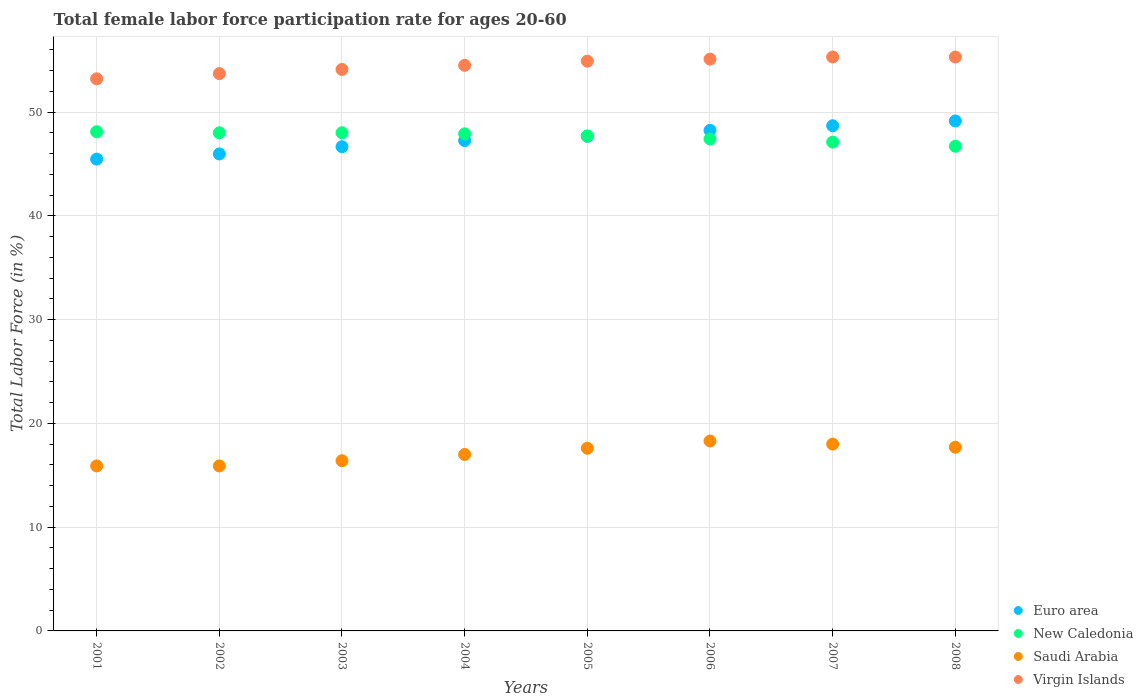What is the female labor force participation rate in Virgin Islands in 2008?
Ensure brevity in your answer.  55.3. Across all years, what is the maximum female labor force participation rate in Virgin Islands?
Your answer should be compact. 55.3. Across all years, what is the minimum female labor force participation rate in New Caledonia?
Offer a very short reply. 46.7. In which year was the female labor force participation rate in Virgin Islands maximum?
Offer a terse response. 2007. In which year was the female labor force participation rate in New Caledonia minimum?
Offer a terse response. 2008. What is the total female labor force participation rate in Saudi Arabia in the graph?
Provide a short and direct response. 136.8. What is the difference between the female labor force participation rate in Virgin Islands in 2001 and that in 2002?
Give a very brief answer. -0.5. What is the difference between the female labor force participation rate in New Caledonia in 2003 and the female labor force participation rate in Virgin Islands in 2001?
Make the answer very short. -5.2. What is the average female labor force participation rate in Euro area per year?
Offer a very short reply. 47.38. In the year 2006, what is the difference between the female labor force participation rate in Saudi Arabia and female labor force participation rate in Euro area?
Give a very brief answer. -29.93. What is the ratio of the female labor force participation rate in Euro area in 2004 to that in 2007?
Your answer should be very brief. 0.97. What is the difference between the highest and the second highest female labor force participation rate in Euro area?
Your answer should be very brief. 0.46. What is the difference between the highest and the lowest female labor force participation rate in Euro area?
Your answer should be very brief. 3.68. Is the sum of the female labor force participation rate in New Caledonia in 2006 and 2007 greater than the maximum female labor force participation rate in Virgin Islands across all years?
Keep it short and to the point. Yes. Is it the case that in every year, the sum of the female labor force participation rate in Saudi Arabia and female labor force participation rate in Euro area  is greater than the sum of female labor force participation rate in New Caledonia and female labor force participation rate in Virgin Islands?
Your response must be concise. No. Is it the case that in every year, the sum of the female labor force participation rate in Euro area and female labor force participation rate in Virgin Islands  is greater than the female labor force participation rate in New Caledonia?
Your answer should be compact. Yes. Is the female labor force participation rate in New Caledonia strictly less than the female labor force participation rate in Virgin Islands over the years?
Give a very brief answer. Yes. How many dotlines are there?
Make the answer very short. 4. Are the values on the major ticks of Y-axis written in scientific E-notation?
Your answer should be compact. No. Does the graph contain any zero values?
Provide a succinct answer. No. Where does the legend appear in the graph?
Offer a terse response. Bottom right. How many legend labels are there?
Your response must be concise. 4. What is the title of the graph?
Make the answer very short. Total female labor force participation rate for ages 20-60. Does "Netherlands" appear as one of the legend labels in the graph?
Ensure brevity in your answer.  No. What is the label or title of the X-axis?
Your answer should be compact. Years. What is the label or title of the Y-axis?
Your answer should be very brief. Total Labor Force (in %). What is the Total Labor Force (in %) of Euro area in 2001?
Your answer should be compact. 45.46. What is the Total Labor Force (in %) of New Caledonia in 2001?
Offer a terse response. 48.1. What is the Total Labor Force (in %) of Saudi Arabia in 2001?
Your answer should be very brief. 15.9. What is the Total Labor Force (in %) of Virgin Islands in 2001?
Ensure brevity in your answer.  53.2. What is the Total Labor Force (in %) of Euro area in 2002?
Provide a succinct answer. 45.96. What is the Total Labor Force (in %) of New Caledonia in 2002?
Provide a succinct answer. 48. What is the Total Labor Force (in %) in Saudi Arabia in 2002?
Offer a terse response. 15.9. What is the Total Labor Force (in %) in Virgin Islands in 2002?
Ensure brevity in your answer.  53.7. What is the Total Labor Force (in %) of Euro area in 2003?
Your response must be concise. 46.66. What is the Total Labor Force (in %) of Saudi Arabia in 2003?
Offer a terse response. 16.4. What is the Total Labor Force (in %) of Virgin Islands in 2003?
Provide a short and direct response. 54.1. What is the Total Labor Force (in %) in Euro area in 2004?
Offer a terse response. 47.25. What is the Total Labor Force (in %) of New Caledonia in 2004?
Give a very brief answer. 47.9. What is the Total Labor Force (in %) of Virgin Islands in 2004?
Provide a short and direct response. 54.5. What is the Total Labor Force (in %) of Euro area in 2005?
Your response must be concise. 47.66. What is the Total Labor Force (in %) in New Caledonia in 2005?
Make the answer very short. 47.7. What is the Total Labor Force (in %) in Saudi Arabia in 2005?
Provide a succinct answer. 17.6. What is the Total Labor Force (in %) of Virgin Islands in 2005?
Keep it short and to the point. 54.9. What is the Total Labor Force (in %) of Euro area in 2006?
Make the answer very short. 48.23. What is the Total Labor Force (in %) of New Caledonia in 2006?
Your response must be concise. 47.4. What is the Total Labor Force (in %) in Saudi Arabia in 2006?
Ensure brevity in your answer.  18.3. What is the Total Labor Force (in %) in Virgin Islands in 2006?
Ensure brevity in your answer.  55.1. What is the Total Labor Force (in %) of Euro area in 2007?
Provide a succinct answer. 48.68. What is the Total Labor Force (in %) of New Caledonia in 2007?
Your answer should be very brief. 47.1. What is the Total Labor Force (in %) of Virgin Islands in 2007?
Offer a very short reply. 55.3. What is the Total Labor Force (in %) in Euro area in 2008?
Give a very brief answer. 49.14. What is the Total Labor Force (in %) in New Caledonia in 2008?
Make the answer very short. 46.7. What is the Total Labor Force (in %) in Saudi Arabia in 2008?
Offer a very short reply. 17.7. What is the Total Labor Force (in %) in Virgin Islands in 2008?
Offer a terse response. 55.3. Across all years, what is the maximum Total Labor Force (in %) of Euro area?
Your answer should be compact. 49.14. Across all years, what is the maximum Total Labor Force (in %) of New Caledonia?
Offer a terse response. 48.1. Across all years, what is the maximum Total Labor Force (in %) of Saudi Arabia?
Make the answer very short. 18.3. Across all years, what is the maximum Total Labor Force (in %) of Virgin Islands?
Provide a succinct answer. 55.3. Across all years, what is the minimum Total Labor Force (in %) in Euro area?
Provide a short and direct response. 45.46. Across all years, what is the minimum Total Labor Force (in %) in New Caledonia?
Provide a succinct answer. 46.7. Across all years, what is the minimum Total Labor Force (in %) of Saudi Arabia?
Provide a short and direct response. 15.9. Across all years, what is the minimum Total Labor Force (in %) of Virgin Islands?
Offer a very short reply. 53.2. What is the total Total Labor Force (in %) in Euro area in the graph?
Ensure brevity in your answer.  379.03. What is the total Total Labor Force (in %) in New Caledonia in the graph?
Offer a very short reply. 380.9. What is the total Total Labor Force (in %) in Saudi Arabia in the graph?
Offer a terse response. 136.8. What is the total Total Labor Force (in %) in Virgin Islands in the graph?
Offer a terse response. 436.1. What is the difference between the Total Labor Force (in %) in Euro area in 2001 and that in 2002?
Ensure brevity in your answer.  -0.5. What is the difference between the Total Labor Force (in %) of Euro area in 2001 and that in 2003?
Ensure brevity in your answer.  -1.2. What is the difference between the Total Labor Force (in %) in Virgin Islands in 2001 and that in 2003?
Provide a succinct answer. -0.9. What is the difference between the Total Labor Force (in %) in Euro area in 2001 and that in 2004?
Provide a succinct answer. -1.78. What is the difference between the Total Labor Force (in %) of Saudi Arabia in 2001 and that in 2004?
Your answer should be compact. -1.1. What is the difference between the Total Labor Force (in %) in Virgin Islands in 2001 and that in 2004?
Ensure brevity in your answer.  -1.3. What is the difference between the Total Labor Force (in %) in Euro area in 2001 and that in 2005?
Provide a succinct answer. -2.2. What is the difference between the Total Labor Force (in %) in New Caledonia in 2001 and that in 2005?
Your response must be concise. 0.4. What is the difference between the Total Labor Force (in %) in Euro area in 2001 and that in 2006?
Offer a very short reply. -2.76. What is the difference between the Total Labor Force (in %) of New Caledonia in 2001 and that in 2006?
Provide a succinct answer. 0.7. What is the difference between the Total Labor Force (in %) in Euro area in 2001 and that in 2007?
Provide a succinct answer. -3.21. What is the difference between the Total Labor Force (in %) of New Caledonia in 2001 and that in 2007?
Give a very brief answer. 1. What is the difference between the Total Labor Force (in %) of Virgin Islands in 2001 and that in 2007?
Your response must be concise. -2.1. What is the difference between the Total Labor Force (in %) of Euro area in 2001 and that in 2008?
Ensure brevity in your answer.  -3.68. What is the difference between the Total Labor Force (in %) of New Caledonia in 2001 and that in 2008?
Offer a very short reply. 1.4. What is the difference between the Total Labor Force (in %) of Virgin Islands in 2001 and that in 2008?
Ensure brevity in your answer.  -2.1. What is the difference between the Total Labor Force (in %) in Euro area in 2002 and that in 2003?
Offer a terse response. -0.7. What is the difference between the Total Labor Force (in %) in New Caledonia in 2002 and that in 2003?
Offer a terse response. 0. What is the difference between the Total Labor Force (in %) in Euro area in 2002 and that in 2004?
Make the answer very short. -1.29. What is the difference between the Total Labor Force (in %) of Euro area in 2002 and that in 2005?
Your answer should be compact. -1.7. What is the difference between the Total Labor Force (in %) in New Caledonia in 2002 and that in 2005?
Offer a terse response. 0.3. What is the difference between the Total Labor Force (in %) of Virgin Islands in 2002 and that in 2005?
Make the answer very short. -1.2. What is the difference between the Total Labor Force (in %) in Euro area in 2002 and that in 2006?
Provide a short and direct response. -2.27. What is the difference between the Total Labor Force (in %) of New Caledonia in 2002 and that in 2006?
Your response must be concise. 0.6. What is the difference between the Total Labor Force (in %) in Virgin Islands in 2002 and that in 2006?
Keep it short and to the point. -1.4. What is the difference between the Total Labor Force (in %) of Euro area in 2002 and that in 2007?
Your answer should be very brief. -2.72. What is the difference between the Total Labor Force (in %) in Saudi Arabia in 2002 and that in 2007?
Your answer should be compact. -2.1. What is the difference between the Total Labor Force (in %) in Euro area in 2002 and that in 2008?
Your answer should be compact. -3.18. What is the difference between the Total Labor Force (in %) in Virgin Islands in 2002 and that in 2008?
Offer a terse response. -1.6. What is the difference between the Total Labor Force (in %) in Euro area in 2003 and that in 2004?
Offer a very short reply. -0.59. What is the difference between the Total Labor Force (in %) in Euro area in 2003 and that in 2005?
Ensure brevity in your answer.  -1. What is the difference between the Total Labor Force (in %) of Virgin Islands in 2003 and that in 2005?
Give a very brief answer. -0.8. What is the difference between the Total Labor Force (in %) of Euro area in 2003 and that in 2006?
Provide a short and direct response. -1.57. What is the difference between the Total Labor Force (in %) in New Caledonia in 2003 and that in 2006?
Provide a succinct answer. 0.6. What is the difference between the Total Labor Force (in %) in Virgin Islands in 2003 and that in 2006?
Ensure brevity in your answer.  -1. What is the difference between the Total Labor Force (in %) in Euro area in 2003 and that in 2007?
Keep it short and to the point. -2.02. What is the difference between the Total Labor Force (in %) of Virgin Islands in 2003 and that in 2007?
Your answer should be very brief. -1.2. What is the difference between the Total Labor Force (in %) in Euro area in 2003 and that in 2008?
Offer a very short reply. -2.48. What is the difference between the Total Labor Force (in %) of New Caledonia in 2003 and that in 2008?
Make the answer very short. 1.3. What is the difference between the Total Labor Force (in %) in Euro area in 2004 and that in 2005?
Offer a very short reply. -0.41. What is the difference between the Total Labor Force (in %) in Saudi Arabia in 2004 and that in 2005?
Your answer should be compact. -0.6. What is the difference between the Total Labor Force (in %) in Euro area in 2004 and that in 2006?
Offer a terse response. -0.98. What is the difference between the Total Labor Force (in %) in New Caledonia in 2004 and that in 2006?
Provide a succinct answer. 0.5. What is the difference between the Total Labor Force (in %) of Saudi Arabia in 2004 and that in 2006?
Make the answer very short. -1.3. What is the difference between the Total Labor Force (in %) in Euro area in 2004 and that in 2007?
Your answer should be compact. -1.43. What is the difference between the Total Labor Force (in %) of New Caledonia in 2004 and that in 2007?
Your response must be concise. 0.8. What is the difference between the Total Labor Force (in %) of Euro area in 2004 and that in 2008?
Your answer should be compact. -1.89. What is the difference between the Total Labor Force (in %) of Saudi Arabia in 2004 and that in 2008?
Keep it short and to the point. -0.7. What is the difference between the Total Labor Force (in %) of Virgin Islands in 2004 and that in 2008?
Your response must be concise. -0.8. What is the difference between the Total Labor Force (in %) in Euro area in 2005 and that in 2006?
Ensure brevity in your answer.  -0.57. What is the difference between the Total Labor Force (in %) of Virgin Islands in 2005 and that in 2006?
Provide a succinct answer. -0.2. What is the difference between the Total Labor Force (in %) of Euro area in 2005 and that in 2007?
Ensure brevity in your answer.  -1.02. What is the difference between the Total Labor Force (in %) of Saudi Arabia in 2005 and that in 2007?
Provide a succinct answer. -0.4. What is the difference between the Total Labor Force (in %) of Euro area in 2005 and that in 2008?
Make the answer very short. -1.48. What is the difference between the Total Labor Force (in %) in Virgin Islands in 2005 and that in 2008?
Make the answer very short. -0.4. What is the difference between the Total Labor Force (in %) of Euro area in 2006 and that in 2007?
Provide a short and direct response. -0.45. What is the difference between the Total Labor Force (in %) in New Caledonia in 2006 and that in 2007?
Offer a very short reply. 0.3. What is the difference between the Total Labor Force (in %) of Saudi Arabia in 2006 and that in 2007?
Keep it short and to the point. 0.3. What is the difference between the Total Labor Force (in %) of Virgin Islands in 2006 and that in 2007?
Your response must be concise. -0.2. What is the difference between the Total Labor Force (in %) in Euro area in 2006 and that in 2008?
Keep it short and to the point. -0.91. What is the difference between the Total Labor Force (in %) in New Caledonia in 2006 and that in 2008?
Keep it short and to the point. 0.7. What is the difference between the Total Labor Force (in %) in Saudi Arabia in 2006 and that in 2008?
Your answer should be very brief. 0.6. What is the difference between the Total Labor Force (in %) in Virgin Islands in 2006 and that in 2008?
Provide a succinct answer. -0.2. What is the difference between the Total Labor Force (in %) in Euro area in 2007 and that in 2008?
Provide a succinct answer. -0.46. What is the difference between the Total Labor Force (in %) of Virgin Islands in 2007 and that in 2008?
Your answer should be compact. 0. What is the difference between the Total Labor Force (in %) of Euro area in 2001 and the Total Labor Force (in %) of New Caledonia in 2002?
Provide a short and direct response. -2.54. What is the difference between the Total Labor Force (in %) in Euro area in 2001 and the Total Labor Force (in %) in Saudi Arabia in 2002?
Ensure brevity in your answer.  29.56. What is the difference between the Total Labor Force (in %) of Euro area in 2001 and the Total Labor Force (in %) of Virgin Islands in 2002?
Provide a short and direct response. -8.24. What is the difference between the Total Labor Force (in %) of New Caledonia in 2001 and the Total Labor Force (in %) of Saudi Arabia in 2002?
Make the answer very short. 32.2. What is the difference between the Total Labor Force (in %) of Saudi Arabia in 2001 and the Total Labor Force (in %) of Virgin Islands in 2002?
Keep it short and to the point. -37.8. What is the difference between the Total Labor Force (in %) of Euro area in 2001 and the Total Labor Force (in %) of New Caledonia in 2003?
Your answer should be very brief. -2.54. What is the difference between the Total Labor Force (in %) of Euro area in 2001 and the Total Labor Force (in %) of Saudi Arabia in 2003?
Keep it short and to the point. 29.06. What is the difference between the Total Labor Force (in %) in Euro area in 2001 and the Total Labor Force (in %) in Virgin Islands in 2003?
Keep it short and to the point. -8.64. What is the difference between the Total Labor Force (in %) of New Caledonia in 2001 and the Total Labor Force (in %) of Saudi Arabia in 2003?
Your answer should be very brief. 31.7. What is the difference between the Total Labor Force (in %) in New Caledonia in 2001 and the Total Labor Force (in %) in Virgin Islands in 2003?
Your answer should be very brief. -6. What is the difference between the Total Labor Force (in %) in Saudi Arabia in 2001 and the Total Labor Force (in %) in Virgin Islands in 2003?
Your answer should be very brief. -38.2. What is the difference between the Total Labor Force (in %) in Euro area in 2001 and the Total Labor Force (in %) in New Caledonia in 2004?
Provide a short and direct response. -2.44. What is the difference between the Total Labor Force (in %) of Euro area in 2001 and the Total Labor Force (in %) of Saudi Arabia in 2004?
Your answer should be compact. 28.46. What is the difference between the Total Labor Force (in %) of Euro area in 2001 and the Total Labor Force (in %) of Virgin Islands in 2004?
Make the answer very short. -9.04. What is the difference between the Total Labor Force (in %) in New Caledonia in 2001 and the Total Labor Force (in %) in Saudi Arabia in 2004?
Provide a short and direct response. 31.1. What is the difference between the Total Labor Force (in %) of Saudi Arabia in 2001 and the Total Labor Force (in %) of Virgin Islands in 2004?
Provide a succinct answer. -38.6. What is the difference between the Total Labor Force (in %) of Euro area in 2001 and the Total Labor Force (in %) of New Caledonia in 2005?
Your answer should be very brief. -2.24. What is the difference between the Total Labor Force (in %) in Euro area in 2001 and the Total Labor Force (in %) in Saudi Arabia in 2005?
Ensure brevity in your answer.  27.86. What is the difference between the Total Labor Force (in %) in Euro area in 2001 and the Total Labor Force (in %) in Virgin Islands in 2005?
Your response must be concise. -9.44. What is the difference between the Total Labor Force (in %) in New Caledonia in 2001 and the Total Labor Force (in %) in Saudi Arabia in 2005?
Your response must be concise. 30.5. What is the difference between the Total Labor Force (in %) of Saudi Arabia in 2001 and the Total Labor Force (in %) of Virgin Islands in 2005?
Your answer should be compact. -39. What is the difference between the Total Labor Force (in %) in Euro area in 2001 and the Total Labor Force (in %) in New Caledonia in 2006?
Your answer should be compact. -1.94. What is the difference between the Total Labor Force (in %) of Euro area in 2001 and the Total Labor Force (in %) of Saudi Arabia in 2006?
Make the answer very short. 27.16. What is the difference between the Total Labor Force (in %) of Euro area in 2001 and the Total Labor Force (in %) of Virgin Islands in 2006?
Give a very brief answer. -9.64. What is the difference between the Total Labor Force (in %) of New Caledonia in 2001 and the Total Labor Force (in %) of Saudi Arabia in 2006?
Provide a short and direct response. 29.8. What is the difference between the Total Labor Force (in %) of Saudi Arabia in 2001 and the Total Labor Force (in %) of Virgin Islands in 2006?
Give a very brief answer. -39.2. What is the difference between the Total Labor Force (in %) of Euro area in 2001 and the Total Labor Force (in %) of New Caledonia in 2007?
Your answer should be very brief. -1.64. What is the difference between the Total Labor Force (in %) of Euro area in 2001 and the Total Labor Force (in %) of Saudi Arabia in 2007?
Your answer should be compact. 27.46. What is the difference between the Total Labor Force (in %) of Euro area in 2001 and the Total Labor Force (in %) of Virgin Islands in 2007?
Your answer should be very brief. -9.84. What is the difference between the Total Labor Force (in %) of New Caledonia in 2001 and the Total Labor Force (in %) of Saudi Arabia in 2007?
Provide a short and direct response. 30.1. What is the difference between the Total Labor Force (in %) in Saudi Arabia in 2001 and the Total Labor Force (in %) in Virgin Islands in 2007?
Provide a short and direct response. -39.4. What is the difference between the Total Labor Force (in %) of Euro area in 2001 and the Total Labor Force (in %) of New Caledonia in 2008?
Give a very brief answer. -1.24. What is the difference between the Total Labor Force (in %) of Euro area in 2001 and the Total Labor Force (in %) of Saudi Arabia in 2008?
Ensure brevity in your answer.  27.76. What is the difference between the Total Labor Force (in %) in Euro area in 2001 and the Total Labor Force (in %) in Virgin Islands in 2008?
Your response must be concise. -9.84. What is the difference between the Total Labor Force (in %) in New Caledonia in 2001 and the Total Labor Force (in %) in Saudi Arabia in 2008?
Your answer should be very brief. 30.4. What is the difference between the Total Labor Force (in %) in New Caledonia in 2001 and the Total Labor Force (in %) in Virgin Islands in 2008?
Your response must be concise. -7.2. What is the difference between the Total Labor Force (in %) in Saudi Arabia in 2001 and the Total Labor Force (in %) in Virgin Islands in 2008?
Offer a very short reply. -39.4. What is the difference between the Total Labor Force (in %) of Euro area in 2002 and the Total Labor Force (in %) of New Caledonia in 2003?
Provide a succinct answer. -2.04. What is the difference between the Total Labor Force (in %) of Euro area in 2002 and the Total Labor Force (in %) of Saudi Arabia in 2003?
Make the answer very short. 29.56. What is the difference between the Total Labor Force (in %) of Euro area in 2002 and the Total Labor Force (in %) of Virgin Islands in 2003?
Your answer should be very brief. -8.14. What is the difference between the Total Labor Force (in %) in New Caledonia in 2002 and the Total Labor Force (in %) in Saudi Arabia in 2003?
Ensure brevity in your answer.  31.6. What is the difference between the Total Labor Force (in %) in Saudi Arabia in 2002 and the Total Labor Force (in %) in Virgin Islands in 2003?
Give a very brief answer. -38.2. What is the difference between the Total Labor Force (in %) in Euro area in 2002 and the Total Labor Force (in %) in New Caledonia in 2004?
Provide a succinct answer. -1.94. What is the difference between the Total Labor Force (in %) in Euro area in 2002 and the Total Labor Force (in %) in Saudi Arabia in 2004?
Your answer should be compact. 28.96. What is the difference between the Total Labor Force (in %) of Euro area in 2002 and the Total Labor Force (in %) of Virgin Islands in 2004?
Make the answer very short. -8.54. What is the difference between the Total Labor Force (in %) in New Caledonia in 2002 and the Total Labor Force (in %) in Saudi Arabia in 2004?
Offer a very short reply. 31. What is the difference between the Total Labor Force (in %) in New Caledonia in 2002 and the Total Labor Force (in %) in Virgin Islands in 2004?
Provide a succinct answer. -6.5. What is the difference between the Total Labor Force (in %) of Saudi Arabia in 2002 and the Total Labor Force (in %) of Virgin Islands in 2004?
Provide a succinct answer. -38.6. What is the difference between the Total Labor Force (in %) in Euro area in 2002 and the Total Labor Force (in %) in New Caledonia in 2005?
Give a very brief answer. -1.74. What is the difference between the Total Labor Force (in %) of Euro area in 2002 and the Total Labor Force (in %) of Saudi Arabia in 2005?
Your answer should be compact. 28.36. What is the difference between the Total Labor Force (in %) in Euro area in 2002 and the Total Labor Force (in %) in Virgin Islands in 2005?
Give a very brief answer. -8.94. What is the difference between the Total Labor Force (in %) of New Caledonia in 2002 and the Total Labor Force (in %) of Saudi Arabia in 2005?
Your response must be concise. 30.4. What is the difference between the Total Labor Force (in %) of New Caledonia in 2002 and the Total Labor Force (in %) of Virgin Islands in 2005?
Give a very brief answer. -6.9. What is the difference between the Total Labor Force (in %) in Saudi Arabia in 2002 and the Total Labor Force (in %) in Virgin Islands in 2005?
Your response must be concise. -39. What is the difference between the Total Labor Force (in %) in Euro area in 2002 and the Total Labor Force (in %) in New Caledonia in 2006?
Offer a very short reply. -1.44. What is the difference between the Total Labor Force (in %) of Euro area in 2002 and the Total Labor Force (in %) of Saudi Arabia in 2006?
Offer a terse response. 27.66. What is the difference between the Total Labor Force (in %) of Euro area in 2002 and the Total Labor Force (in %) of Virgin Islands in 2006?
Keep it short and to the point. -9.14. What is the difference between the Total Labor Force (in %) in New Caledonia in 2002 and the Total Labor Force (in %) in Saudi Arabia in 2006?
Ensure brevity in your answer.  29.7. What is the difference between the Total Labor Force (in %) in New Caledonia in 2002 and the Total Labor Force (in %) in Virgin Islands in 2006?
Offer a terse response. -7.1. What is the difference between the Total Labor Force (in %) in Saudi Arabia in 2002 and the Total Labor Force (in %) in Virgin Islands in 2006?
Your response must be concise. -39.2. What is the difference between the Total Labor Force (in %) of Euro area in 2002 and the Total Labor Force (in %) of New Caledonia in 2007?
Provide a succinct answer. -1.14. What is the difference between the Total Labor Force (in %) in Euro area in 2002 and the Total Labor Force (in %) in Saudi Arabia in 2007?
Make the answer very short. 27.96. What is the difference between the Total Labor Force (in %) in Euro area in 2002 and the Total Labor Force (in %) in Virgin Islands in 2007?
Ensure brevity in your answer.  -9.34. What is the difference between the Total Labor Force (in %) in New Caledonia in 2002 and the Total Labor Force (in %) in Saudi Arabia in 2007?
Make the answer very short. 30. What is the difference between the Total Labor Force (in %) of Saudi Arabia in 2002 and the Total Labor Force (in %) of Virgin Islands in 2007?
Provide a succinct answer. -39.4. What is the difference between the Total Labor Force (in %) in Euro area in 2002 and the Total Labor Force (in %) in New Caledonia in 2008?
Give a very brief answer. -0.74. What is the difference between the Total Labor Force (in %) of Euro area in 2002 and the Total Labor Force (in %) of Saudi Arabia in 2008?
Your response must be concise. 28.26. What is the difference between the Total Labor Force (in %) of Euro area in 2002 and the Total Labor Force (in %) of Virgin Islands in 2008?
Offer a very short reply. -9.34. What is the difference between the Total Labor Force (in %) in New Caledonia in 2002 and the Total Labor Force (in %) in Saudi Arabia in 2008?
Offer a very short reply. 30.3. What is the difference between the Total Labor Force (in %) of Saudi Arabia in 2002 and the Total Labor Force (in %) of Virgin Islands in 2008?
Your answer should be very brief. -39.4. What is the difference between the Total Labor Force (in %) in Euro area in 2003 and the Total Labor Force (in %) in New Caledonia in 2004?
Provide a short and direct response. -1.24. What is the difference between the Total Labor Force (in %) of Euro area in 2003 and the Total Labor Force (in %) of Saudi Arabia in 2004?
Provide a short and direct response. 29.66. What is the difference between the Total Labor Force (in %) of Euro area in 2003 and the Total Labor Force (in %) of Virgin Islands in 2004?
Keep it short and to the point. -7.84. What is the difference between the Total Labor Force (in %) of Saudi Arabia in 2003 and the Total Labor Force (in %) of Virgin Islands in 2004?
Your answer should be very brief. -38.1. What is the difference between the Total Labor Force (in %) of Euro area in 2003 and the Total Labor Force (in %) of New Caledonia in 2005?
Your answer should be compact. -1.04. What is the difference between the Total Labor Force (in %) of Euro area in 2003 and the Total Labor Force (in %) of Saudi Arabia in 2005?
Keep it short and to the point. 29.06. What is the difference between the Total Labor Force (in %) of Euro area in 2003 and the Total Labor Force (in %) of Virgin Islands in 2005?
Your response must be concise. -8.24. What is the difference between the Total Labor Force (in %) of New Caledonia in 2003 and the Total Labor Force (in %) of Saudi Arabia in 2005?
Your answer should be very brief. 30.4. What is the difference between the Total Labor Force (in %) in New Caledonia in 2003 and the Total Labor Force (in %) in Virgin Islands in 2005?
Give a very brief answer. -6.9. What is the difference between the Total Labor Force (in %) in Saudi Arabia in 2003 and the Total Labor Force (in %) in Virgin Islands in 2005?
Your answer should be compact. -38.5. What is the difference between the Total Labor Force (in %) in Euro area in 2003 and the Total Labor Force (in %) in New Caledonia in 2006?
Offer a terse response. -0.74. What is the difference between the Total Labor Force (in %) in Euro area in 2003 and the Total Labor Force (in %) in Saudi Arabia in 2006?
Offer a very short reply. 28.36. What is the difference between the Total Labor Force (in %) of Euro area in 2003 and the Total Labor Force (in %) of Virgin Islands in 2006?
Provide a short and direct response. -8.44. What is the difference between the Total Labor Force (in %) in New Caledonia in 2003 and the Total Labor Force (in %) in Saudi Arabia in 2006?
Ensure brevity in your answer.  29.7. What is the difference between the Total Labor Force (in %) in Saudi Arabia in 2003 and the Total Labor Force (in %) in Virgin Islands in 2006?
Keep it short and to the point. -38.7. What is the difference between the Total Labor Force (in %) of Euro area in 2003 and the Total Labor Force (in %) of New Caledonia in 2007?
Provide a succinct answer. -0.44. What is the difference between the Total Labor Force (in %) of Euro area in 2003 and the Total Labor Force (in %) of Saudi Arabia in 2007?
Your response must be concise. 28.66. What is the difference between the Total Labor Force (in %) in Euro area in 2003 and the Total Labor Force (in %) in Virgin Islands in 2007?
Offer a very short reply. -8.64. What is the difference between the Total Labor Force (in %) of New Caledonia in 2003 and the Total Labor Force (in %) of Saudi Arabia in 2007?
Keep it short and to the point. 30. What is the difference between the Total Labor Force (in %) in Saudi Arabia in 2003 and the Total Labor Force (in %) in Virgin Islands in 2007?
Offer a very short reply. -38.9. What is the difference between the Total Labor Force (in %) in Euro area in 2003 and the Total Labor Force (in %) in New Caledonia in 2008?
Offer a terse response. -0.04. What is the difference between the Total Labor Force (in %) of Euro area in 2003 and the Total Labor Force (in %) of Saudi Arabia in 2008?
Your response must be concise. 28.96. What is the difference between the Total Labor Force (in %) of Euro area in 2003 and the Total Labor Force (in %) of Virgin Islands in 2008?
Your answer should be compact. -8.64. What is the difference between the Total Labor Force (in %) of New Caledonia in 2003 and the Total Labor Force (in %) of Saudi Arabia in 2008?
Your response must be concise. 30.3. What is the difference between the Total Labor Force (in %) of New Caledonia in 2003 and the Total Labor Force (in %) of Virgin Islands in 2008?
Make the answer very short. -7.3. What is the difference between the Total Labor Force (in %) in Saudi Arabia in 2003 and the Total Labor Force (in %) in Virgin Islands in 2008?
Your response must be concise. -38.9. What is the difference between the Total Labor Force (in %) in Euro area in 2004 and the Total Labor Force (in %) in New Caledonia in 2005?
Make the answer very short. -0.45. What is the difference between the Total Labor Force (in %) of Euro area in 2004 and the Total Labor Force (in %) of Saudi Arabia in 2005?
Your response must be concise. 29.65. What is the difference between the Total Labor Force (in %) in Euro area in 2004 and the Total Labor Force (in %) in Virgin Islands in 2005?
Your answer should be compact. -7.65. What is the difference between the Total Labor Force (in %) in New Caledonia in 2004 and the Total Labor Force (in %) in Saudi Arabia in 2005?
Offer a very short reply. 30.3. What is the difference between the Total Labor Force (in %) in Saudi Arabia in 2004 and the Total Labor Force (in %) in Virgin Islands in 2005?
Provide a succinct answer. -37.9. What is the difference between the Total Labor Force (in %) of Euro area in 2004 and the Total Labor Force (in %) of New Caledonia in 2006?
Your answer should be compact. -0.15. What is the difference between the Total Labor Force (in %) of Euro area in 2004 and the Total Labor Force (in %) of Saudi Arabia in 2006?
Your answer should be very brief. 28.95. What is the difference between the Total Labor Force (in %) of Euro area in 2004 and the Total Labor Force (in %) of Virgin Islands in 2006?
Your answer should be compact. -7.85. What is the difference between the Total Labor Force (in %) of New Caledonia in 2004 and the Total Labor Force (in %) of Saudi Arabia in 2006?
Make the answer very short. 29.6. What is the difference between the Total Labor Force (in %) of Saudi Arabia in 2004 and the Total Labor Force (in %) of Virgin Islands in 2006?
Provide a succinct answer. -38.1. What is the difference between the Total Labor Force (in %) in Euro area in 2004 and the Total Labor Force (in %) in New Caledonia in 2007?
Make the answer very short. 0.15. What is the difference between the Total Labor Force (in %) of Euro area in 2004 and the Total Labor Force (in %) of Saudi Arabia in 2007?
Ensure brevity in your answer.  29.25. What is the difference between the Total Labor Force (in %) in Euro area in 2004 and the Total Labor Force (in %) in Virgin Islands in 2007?
Offer a very short reply. -8.05. What is the difference between the Total Labor Force (in %) in New Caledonia in 2004 and the Total Labor Force (in %) in Saudi Arabia in 2007?
Offer a very short reply. 29.9. What is the difference between the Total Labor Force (in %) of New Caledonia in 2004 and the Total Labor Force (in %) of Virgin Islands in 2007?
Provide a succinct answer. -7.4. What is the difference between the Total Labor Force (in %) of Saudi Arabia in 2004 and the Total Labor Force (in %) of Virgin Islands in 2007?
Ensure brevity in your answer.  -38.3. What is the difference between the Total Labor Force (in %) in Euro area in 2004 and the Total Labor Force (in %) in New Caledonia in 2008?
Keep it short and to the point. 0.55. What is the difference between the Total Labor Force (in %) in Euro area in 2004 and the Total Labor Force (in %) in Saudi Arabia in 2008?
Provide a short and direct response. 29.55. What is the difference between the Total Labor Force (in %) of Euro area in 2004 and the Total Labor Force (in %) of Virgin Islands in 2008?
Give a very brief answer. -8.05. What is the difference between the Total Labor Force (in %) in New Caledonia in 2004 and the Total Labor Force (in %) in Saudi Arabia in 2008?
Ensure brevity in your answer.  30.2. What is the difference between the Total Labor Force (in %) of New Caledonia in 2004 and the Total Labor Force (in %) of Virgin Islands in 2008?
Ensure brevity in your answer.  -7.4. What is the difference between the Total Labor Force (in %) in Saudi Arabia in 2004 and the Total Labor Force (in %) in Virgin Islands in 2008?
Keep it short and to the point. -38.3. What is the difference between the Total Labor Force (in %) in Euro area in 2005 and the Total Labor Force (in %) in New Caledonia in 2006?
Provide a short and direct response. 0.26. What is the difference between the Total Labor Force (in %) in Euro area in 2005 and the Total Labor Force (in %) in Saudi Arabia in 2006?
Give a very brief answer. 29.36. What is the difference between the Total Labor Force (in %) of Euro area in 2005 and the Total Labor Force (in %) of Virgin Islands in 2006?
Keep it short and to the point. -7.44. What is the difference between the Total Labor Force (in %) of New Caledonia in 2005 and the Total Labor Force (in %) of Saudi Arabia in 2006?
Provide a short and direct response. 29.4. What is the difference between the Total Labor Force (in %) of Saudi Arabia in 2005 and the Total Labor Force (in %) of Virgin Islands in 2006?
Your answer should be compact. -37.5. What is the difference between the Total Labor Force (in %) of Euro area in 2005 and the Total Labor Force (in %) of New Caledonia in 2007?
Give a very brief answer. 0.56. What is the difference between the Total Labor Force (in %) of Euro area in 2005 and the Total Labor Force (in %) of Saudi Arabia in 2007?
Your response must be concise. 29.66. What is the difference between the Total Labor Force (in %) in Euro area in 2005 and the Total Labor Force (in %) in Virgin Islands in 2007?
Your answer should be compact. -7.64. What is the difference between the Total Labor Force (in %) in New Caledonia in 2005 and the Total Labor Force (in %) in Saudi Arabia in 2007?
Make the answer very short. 29.7. What is the difference between the Total Labor Force (in %) in New Caledonia in 2005 and the Total Labor Force (in %) in Virgin Islands in 2007?
Your answer should be very brief. -7.6. What is the difference between the Total Labor Force (in %) in Saudi Arabia in 2005 and the Total Labor Force (in %) in Virgin Islands in 2007?
Your answer should be very brief. -37.7. What is the difference between the Total Labor Force (in %) of Euro area in 2005 and the Total Labor Force (in %) of New Caledonia in 2008?
Your answer should be compact. 0.96. What is the difference between the Total Labor Force (in %) in Euro area in 2005 and the Total Labor Force (in %) in Saudi Arabia in 2008?
Provide a succinct answer. 29.96. What is the difference between the Total Labor Force (in %) in Euro area in 2005 and the Total Labor Force (in %) in Virgin Islands in 2008?
Provide a succinct answer. -7.64. What is the difference between the Total Labor Force (in %) in New Caledonia in 2005 and the Total Labor Force (in %) in Saudi Arabia in 2008?
Ensure brevity in your answer.  30. What is the difference between the Total Labor Force (in %) in New Caledonia in 2005 and the Total Labor Force (in %) in Virgin Islands in 2008?
Make the answer very short. -7.6. What is the difference between the Total Labor Force (in %) of Saudi Arabia in 2005 and the Total Labor Force (in %) of Virgin Islands in 2008?
Ensure brevity in your answer.  -37.7. What is the difference between the Total Labor Force (in %) in Euro area in 2006 and the Total Labor Force (in %) in New Caledonia in 2007?
Your answer should be compact. 1.13. What is the difference between the Total Labor Force (in %) in Euro area in 2006 and the Total Labor Force (in %) in Saudi Arabia in 2007?
Offer a terse response. 30.23. What is the difference between the Total Labor Force (in %) of Euro area in 2006 and the Total Labor Force (in %) of Virgin Islands in 2007?
Ensure brevity in your answer.  -7.07. What is the difference between the Total Labor Force (in %) in New Caledonia in 2006 and the Total Labor Force (in %) in Saudi Arabia in 2007?
Offer a very short reply. 29.4. What is the difference between the Total Labor Force (in %) in Saudi Arabia in 2006 and the Total Labor Force (in %) in Virgin Islands in 2007?
Keep it short and to the point. -37. What is the difference between the Total Labor Force (in %) of Euro area in 2006 and the Total Labor Force (in %) of New Caledonia in 2008?
Provide a short and direct response. 1.53. What is the difference between the Total Labor Force (in %) in Euro area in 2006 and the Total Labor Force (in %) in Saudi Arabia in 2008?
Your answer should be compact. 30.53. What is the difference between the Total Labor Force (in %) in Euro area in 2006 and the Total Labor Force (in %) in Virgin Islands in 2008?
Make the answer very short. -7.07. What is the difference between the Total Labor Force (in %) in New Caledonia in 2006 and the Total Labor Force (in %) in Saudi Arabia in 2008?
Your answer should be very brief. 29.7. What is the difference between the Total Labor Force (in %) in Saudi Arabia in 2006 and the Total Labor Force (in %) in Virgin Islands in 2008?
Provide a succinct answer. -37. What is the difference between the Total Labor Force (in %) in Euro area in 2007 and the Total Labor Force (in %) in New Caledonia in 2008?
Offer a terse response. 1.98. What is the difference between the Total Labor Force (in %) in Euro area in 2007 and the Total Labor Force (in %) in Saudi Arabia in 2008?
Offer a terse response. 30.98. What is the difference between the Total Labor Force (in %) in Euro area in 2007 and the Total Labor Force (in %) in Virgin Islands in 2008?
Provide a short and direct response. -6.62. What is the difference between the Total Labor Force (in %) in New Caledonia in 2007 and the Total Labor Force (in %) in Saudi Arabia in 2008?
Keep it short and to the point. 29.4. What is the difference between the Total Labor Force (in %) of New Caledonia in 2007 and the Total Labor Force (in %) of Virgin Islands in 2008?
Keep it short and to the point. -8.2. What is the difference between the Total Labor Force (in %) in Saudi Arabia in 2007 and the Total Labor Force (in %) in Virgin Islands in 2008?
Your answer should be very brief. -37.3. What is the average Total Labor Force (in %) in Euro area per year?
Offer a very short reply. 47.38. What is the average Total Labor Force (in %) of New Caledonia per year?
Ensure brevity in your answer.  47.61. What is the average Total Labor Force (in %) of Saudi Arabia per year?
Your response must be concise. 17.1. What is the average Total Labor Force (in %) of Virgin Islands per year?
Your answer should be compact. 54.51. In the year 2001, what is the difference between the Total Labor Force (in %) in Euro area and Total Labor Force (in %) in New Caledonia?
Offer a terse response. -2.64. In the year 2001, what is the difference between the Total Labor Force (in %) of Euro area and Total Labor Force (in %) of Saudi Arabia?
Your answer should be very brief. 29.56. In the year 2001, what is the difference between the Total Labor Force (in %) of Euro area and Total Labor Force (in %) of Virgin Islands?
Your answer should be very brief. -7.74. In the year 2001, what is the difference between the Total Labor Force (in %) of New Caledonia and Total Labor Force (in %) of Saudi Arabia?
Ensure brevity in your answer.  32.2. In the year 2001, what is the difference between the Total Labor Force (in %) of Saudi Arabia and Total Labor Force (in %) of Virgin Islands?
Provide a succinct answer. -37.3. In the year 2002, what is the difference between the Total Labor Force (in %) in Euro area and Total Labor Force (in %) in New Caledonia?
Your response must be concise. -2.04. In the year 2002, what is the difference between the Total Labor Force (in %) of Euro area and Total Labor Force (in %) of Saudi Arabia?
Make the answer very short. 30.06. In the year 2002, what is the difference between the Total Labor Force (in %) in Euro area and Total Labor Force (in %) in Virgin Islands?
Your answer should be very brief. -7.74. In the year 2002, what is the difference between the Total Labor Force (in %) of New Caledonia and Total Labor Force (in %) of Saudi Arabia?
Provide a succinct answer. 32.1. In the year 2002, what is the difference between the Total Labor Force (in %) in New Caledonia and Total Labor Force (in %) in Virgin Islands?
Your answer should be very brief. -5.7. In the year 2002, what is the difference between the Total Labor Force (in %) in Saudi Arabia and Total Labor Force (in %) in Virgin Islands?
Keep it short and to the point. -37.8. In the year 2003, what is the difference between the Total Labor Force (in %) in Euro area and Total Labor Force (in %) in New Caledonia?
Your answer should be very brief. -1.34. In the year 2003, what is the difference between the Total Labor Force (in %) of Euro area and Total Labor Force (in %) of Saudi Arabia?
Make the answer very short. 30.26. In the year 2003, what is the difference between the Total Labor Force (in %) in Euro area and Total Labor Force (in %) in Virgin Islands?
Provide a succinct answer. -7.44. In the year 2003, what is the difference between the Total Labor Force (in %) of New Caledonia and Total Labor Force (in %) of Saudi Arabia?
Give a very brief answer. 31.6. In the year 2003, what is the difference between the Total Labor Force (in %) of New Caledonia and Total Labor Force (in %) of Virgin Islands?
Provide a succinct answer. -6.1. In the year 2003, what is the difference between the Total Labor Force (in %) of Saudi Arabia and Total Labor Force (in %) of Virgin Islands?
Offer a very short reply. -37.7. In the year 2004, what is the difference between the Total Labor Force (in %) in Euro area and Total Labor Force (in %) in New Caledonia?
Provide a short and direct response. -0.65. In the year 2004, what is the difference between the Total Labor Force (in %) in Euro area and Total Labor Force (in %) in Saudi Arabia?
Your answer should be compact. 30.25. In the year 2004, what is the difference between the Total Labor Force (in %) of Euro area and Total Labor Force (in %) of Virgin Islands?
Keep it short and to the point. -7.25. In the year 2004, what is the difference between the Total Labor Force (in %) in New Caledonia and Total Labor Force (in %) in Saudi Arabia?
Make the answer very short. 30.9. In the year 2004, what is the difference between the Total Labor Force (in %) in New Caledonia and Total Labor Force (in %) in Virgin Islands?
Make the answer very short. -6.6. In the year 2004, what is the difference between the Total Labor Force (in %) of Saudi Arabia and Total Labor Force (in %) of Virgin Islands?
Give a very brief answer. -37.5. In the year 2005, what is the difference between the Total Labor Force (in %) in Euro area and Total Labor Force (in %) in New Caledonia?
Your answer should be very brief. -0.04. In the year 2005, what is the difference between the Total Labor Force (in %) in Euro area and Total Labor Force (in %) in Saudi Arabia?
Offer a very short reply. 30.06. In the year 2005, what is the difference between the Total Labor Force (in %) of Euro area and Total Labor Force (in %) of Virgin Islands?
Your answer should be compact. -7.24. In the year 2005, what is the difference between the Total Labor Force (in %) of New Caledonia and Total Labor Force (in %) of Saudi Arabia?
Your answer should be very brief. 30.1. In the year 2005, what is the difference between the Total Labor Force (in %) in New Caledonia and Total Labor Force (in %) in Virgin Islands?
Provide a succinct answer. -7.2. In the year 2005, what is the difference between the Total Labor Force (in %) of Saudi Arabia and Total Labor Force (in %) of Virgin Islands?
Make the answer very short. -37.3. In the year 2006, what is the difference between the Total Labor Force (in %) in Euro area and Total Labor Force (in %) in New Caledonia?
Ensure brevity in your answer.  0.83. In the year 2006, what is the difference between the Total Labor Force (in %) of Euro area and Total Labor Force (in %) of Saudi Arabia?
Your answer should be very brief. 29.93. In the year 2006, what is the difference between the Total Labor Force (in %) of Euro area and Total Labor Force (in %) of Virgin Islands?
Your answer should be compact. -6.87. In the year 2006, what is the difference between the Total Labor Force (in %) in New Caledonia and Total Labor Force (in %) in Saudi Arabia?
Give a very brief answer. 29.1. In the year 2006, what is the difference between the Total Labor Force (in %) in New Caledonia and Total Labor Force (in %) in Virgin Islands?
Your answer should be compact. -7.7. In the year 2006, what is the difference between the Total Labor Force (in %) of Saudi Arabia and Total Labor Force (in %) of Virgin Islands?
Ensure brevity in your answer.  -36.8. In the year 2007, what is the difference between the Total Labor Force (in %) in Euro area and Total Labor Force (in %) in New Caledonia?
Offer a very short reply. 1.58. In the year 2007, what is the difference between the Total Labor Force (in %) of Euro area and Total Labor Force (in %) of Saudi Arabia?
Offer a very short reply. 30.68. In the year 2007, what is the difference between the Total Labor Force (in %) of Euro area and Total Labor Force (in %) of Virgin Islands?
Your answer should be very brief. -6.62. In the year 2007, what is the difference between the Total Labor Force (in %) of New Caledonia and Total Labor Force (in %) of Saudi Arabia?
Give a very brief answer. 29.1. In the year 2007, what is the difference between the Total Labor Force (in %) in New Caledonia and Total Labor Force (in %) in Virgin Islands?
Offer a terse response. -8.2. In the year 2007, what is the difference between the Total Labor Force (in %) in Saudi Arabia and Total Labor Force (in %) in Virgin Islands?
Offer a very short reply. -37.3. In the year 2008, what is the difference between the Total Labor Force (in %) of Euro area and Total Labor Force (in %) of New Caledonia?
Offer a terse response. 2.44. In the year 2008, what is the difference between the Total Labor Force (in %) in Euro area and Total Labor Force (in %) in Saudi Arabia?
Give a very brief answer. 31.44. In the year 2008, what is the difference between the Total Labor Force (in %) of Euro area and Total Labor Force (in %) of Virgin Islands?
Your answer should be compact. -6.16. In the year 2008, what is the difference between the Total Labor Force (in %) of New Caledonia and Total Labor Force (in %) of Virgin Islands?
Make the answer very short. -8.6. In the year 2008, what is the difference between the Total Labor Force (in %) of Saudi Arabia and Total Labor Force (in %) of Virgin Islands?
Your response must be concise. -37.6. What is the ratio of the Total Labor Force (in %) of Euro area in 2001 to that in 2002?
Offer a terse response. 0.99. What is the ratio of the Total Labor Force (in %) of New Caledonia in 2001 to that in 2002?
Keep it short and to the point. 1. What is the ratio of the Total Labor Force (in %) of Euro area in 2001 to that in 2003?
Keep it short and to the point. 0.97. What is the ratio of the Total Labor Force (in %) of New Caledonia in 2001 to that in 2003?
Your answer should be compact. 1. What is the ratio of the Total Labor Force (in %) of Saudi Arabia in 2001 to that in 2003?
Ensure brevity in your answer.  0.97. What is the ratio of the Total Labor Force (in %) of Virgin Islands in 2001 to that in 2003?
Your answer should be very brief. 0.98. What is the ratio of the Total Labor Force (in %) of Euro area in 2001 to that in 2004?
Offer a very short reply. 0.96. What is the ratio of the Total Labor Force (in %) of Saudi Arabia in 2001 to that in 2004?
Provide a succinct answer. 0.94. What is the ratio of the Total Labor Force (in %) of Virgin Islands in 2001 to that in 2004?
Give a very brief answer. 0.98. What is the ratio of the Total Labor Force (in %) in Euro area in 2001 to that in 2005?
Offer a very short reply. 0.95. What is the ratio of the Total Labor Force (in %) of New Caledonia in 2001 to that in 2005?
Ensure brevity in your answer.  1.01. What is the ratio of the Total Labor Force (in %) of Saudi Arabia in 2001 to that in 2005?
Give a very brief answer. 0.9. What is the ratio of the Total Labor Force (in %) of Virgin Islands in 2001 to that in 2005?
Keep it short and to the point. 0.97. What is the ratio of the Total Labor Force (in %) in Euro area in 2001 to that in 2006?
Offer a very short reply. 0.94. What is the ratio of the Total Labor Force (in %) in New Caledonia in 2001 to that in 2006?
Make the answer very short. 1.01. What is the ratio of the Total Labor Force (in %) in Saudi Arabia in 2001 to that in 2006?
Keep it short and to the point. 0.87. What is the ratio of the Total Labor Force (in %) in Virgin Islands in 2001 to that in 2006?
Give a very brief answer. 0.97. What is the ratio of the Total Labor Force (in %) of Euro area in 2001 to that in 2007?
Offer a very short reply. 0.93. What is the ratio of the Total Labor Force (in %) of New Caledonia in 2001 to that in 2007?
Keep it short and to the point. 1.02. What is the ratio of the Total Labor Force (in %) in Saudi Arabia in 2001 to that in 2007?
Make the answer very short. 0.88. What is the ratio of the Total Labor Force (in %) in Euro area in 2001 to that in 2008?
Your response must be concise. 0.93. What is the ratio of the Total Labor Force (in %) in New Caledonia in 2001 to that in 2008?
Ensure brevity in your answer.  1.03. What is the ratio of the Total Labor Force (in %) of Saudi Arabia in 2001 to that in 2008?
Your response must be concise. 0.9. What is the ratio of the Total Labor Force (in %) of New Caledonia in 2002 to that in 2003?
Provide a succinct answer. 1. What is the ratio of the Total Labor Force (in %) of Saudi Arabia in 2002 to that in 2003?
Make the answer very short. 0.97. What is the ratio of the Total Labor Force (in %) of Virgin Islands in 2002 to that in 2003?
Offer a terse response. 0.99. What is the ratio of the Total Labor Force (in %) of Euro area in 2002 to that in 2004?
Offer a very short reply. 0.97. What is the ratio of the Total Labor Force (in %) in New Caledonia in 2002 to that in 2004?
Give a very brief answer. 1. What is the ratio of the Total Labor Force (in %) in Saudi Arabia in 2002 to that in 2004?
Your answer should be very brief. 0.94. What is the ratio of the Total Labor Force (in %) in Saudi Arabia in 2002 to that in 2005?
Provide a short and direct response. 0.9. What is the ratio of the Total Labor Force (in %) in Virgin Islands in 2002 to that in 2005?
Keep it short and to the point. 0.98. What is the ratio of the Total Labor Force (in %) in Euro area in 2002 to that in 2006?
Your answer should be compact. 0.95. What is the ratio of the Total Labor Force (in %) of New Caledonia in 2002 to that in 2006?
Your answer should be compact. 1.01. What is the ratio of the Total Labor Force (in %) in Saudi Arabia in 2002 to that in 2006?
Your response must be concise. 0.87. What is the ratio of the Total Labor Force (in %) in Virgin Islands in 2002 to that in 2006?
Give a very brief answer. 0.97. What is the ratio of the Total Labor Force (in %) in Euro area in 2002 to that in 2007?
Your response must be concise. 0.94. What is the ratio of the Total Labor Force (in %) in New Caledonia in 2002 to that in 2007?
Offer a terse response. 1.02. What is the ratio of the Total Labor Force (in %) of Saudi Arabia in 2002 to that in 2007?
Provide a succinct answer. 0.88. What is the ratio of the Total Labor Force (in %) of Virgin Islands in 2002 to that in 2007?
Your response must be concise. 0.97. What is the ratio of the Total Labor Force (in %) in Euro area in 2002 to that in 2008?
Your response must be concise. 0.94. What is the ratio of the Total Labor Force (in %) in New Caledonia in 2002 to that in 2008?
Your answer should be very brief. 1.03. What is the ratio of the Total Labor Force (in %) of Saudi Arabia in 2002 to that in 2008?
Your answer should be very brief. 0.9. What is the ratio of the Total Labor Force (in %) of Virgin Islands in 2002 to that in 2008?
Provide a succinct answer. 0.97. What is the ratio of the Total Labor Force (in %) of Euro area in 2003 to that in 2004?
Offer a terse response. 0.99. What is the ratio of the Total Labor Force (in %) of New Caledonia in 2003 to that in 2004?
Your response must be concise. 1. What is the ratio of the Total Labor Force (in %) of Saudi Arabia in 2003 to that in 2004?
Make the answer very short. 0.96. What is the ratio of the Total Labor Force (in %) of New Caledonia in 2003 to that in 2005?
Make the answer very short. 1.01. What is the ratio of the Total Labor Force (in %) in Saudi Arabia in 2003 to that in 2005?
Your response must be concise. 0.93. What is the ratio of the Total Labor Force (in %) in Virgin Islands in 2003 to that in 2005?
Provide a short and direct response. 0.99. What is the ratio of the Total Labor Force (in %) of Euro area in 2003 to that in 2006?
Provide a short and direct response. 0.97. What is the ratio of the Total Labor Force (in %) of New Caledonia in 2003 to that in 2006?
Your answer should be very brief. 1.01. What is the ratio of the Total Labor Force (in %) in Saudi Arabia in 2003 to that in 2006?
Give a very brief answer. 0.9. What is the ratio of the Total Labor Force (in %) in Virgin Islands in 2003 to that in 2006?
Your response must be concise. 0.98. What is the ratio of the Total Labor Force (in %) of Euro area in 2003 to that in 2007?
Your answer should be compact. 0.96. What is the ratio of the Total Labor Force (in %) of New Caledonia in 2003 to that in 2007?
Your answer should be compact. 1.02. What is the ratio of the Total Labor Force (in %) in Saudi Arabia in 2003 to that in 2007?
Offer a terse response. 0.91. What is the ratio of the Total Labor Force (in %) of Virgin Islands in 2003 to that in 2007?
Give a very brief answer. 0.98. What is the ratio of the Total Labor Force (in %) of Euro area in 2003 to that in 2008?
Provide a short and direct response. 0.95. What is the ratio of the Total Labor Force (in %) of New Caledonia in 2003 to that in 2008?
Offer a very short reply. 1.03. What is the ratio of the Total Labor Force (in %) of Saudi Arabia in 2003 to that in 2008?
Your response must be concise. 0.93. What is the ratio of the Total Labor Force (in %) of Virgin Islands in 2003 to that in 2008?
Keep it short and to the point. 0.98. What is the ratio of the Total Labor Force (in %) of Euro area in 2004 to that in 2005?
Offer a terse response. 0.99. What is the ratio of the Total Labor Force (in %) of New Caledonia in 2004 to that in 2005?
Offer a terse response. 1. What is the ratio of the Total Labor Force (in %) of Saudi Arabia in 2004 to that in 2005?
Ensure brevity in your answer.  0.97. What is the ratio of the Total Labor Force (in %) in Virgin Islands in 2004 to that in 2005?
Provide a short and direct response. 0.99. What is the ratio of the Total Labor Force (in %) of Euro area in 2004 to that in 2006?
Make the answer very short. 0.98. What is the ratio of the Total Labor Force (in %) in New Caledonia in 2004 to that in 2006?
Offer a very short reply. 1.01. What is the ratio of the Total Labor Force (in %) in Saudi Arabia in 2004 to that in 2006?
Offer a very short reply. 0.93. What is the ratio of the Total Labor Force (in %) of Euro area in 2004 to that in 2007?
Your answer should be very brief. 0.97. What is the ratio of the Total Labor Force (in %) of Saudi Arabia in 2004 to that in 2007?
Your answer should be compact. 0.94. What is the ratio of the Total Labor Force (in %) of Virgin Islands in 2004 to that in 2007?
Offer a very short reply. 0.99. What is the ratio of the Total Labor Force (in %) of Euro area in 2004 to that in 2008?
Provide a succinct answer. 0.96. What is the ratio of the Total Labor Force (in %) of New Caledonia in 2004 to that in 2008?
Offer a terse response. 1.03. What is the ratio of the Total Labor Force (in %) of Saudi Arabia in 2004 to that in 2008?
Ensure brevity in your answer.  0.96. What is the ratio of the Total Labor Force (in %) in Virgin Islands in 2004 to that in 2008?
Your response must be concise. 0.99. What is the ratio of the Total Labor Force (in %) of Saudi Arabia in 2005 to that in 2006?
Provide a short and direct response. 0.96. What is the ratio of the Total Labor Force (in %) in Virgin Islands in 2005 to that in 2006?
Offer a terse response. 1. What is the ratio of the Total Labor Force (in %) of Euro area in 2005 to that in 2007?
Your answer should be very brief. 0.98. What is the ratio of the Total Labor Force (in %) of New Caledonia in 2005 to that in 2007?
Your answer should be compact. 1.01. What is the ratio of the Total Labor Force (in %) of Saudi Arabia in 2005 to that in 2007?
Offer a very short reply. 0.98. What is the ratio of the Total Labor Force (in %) of Euro area in 2005 to that in 2008?
Ensure brevity in your answer.  0.97. What is the ratio of the Total Labor Force (in %) in New Caledonia in 2005 to that in 2008?
Offer a terse response. 1.02. What is the ratio of the Total Labor Force (in %) in New Caledonia in 2006 to that in 2007?
Offer a terse response. 1.01. What is the ratio of the Total Labor Force (in %) of Saudi Arabia in 2006 to that in 2007?
Ensure brevity in your answer.  1.02. What is the ratio of the Total Labor Force (in %) of Euro area in 2006 to that in 2008?
Your answer should be very brief. 0.98. What is the ratio of the Total Labor Force (in %) of Saudi Arabia in 2006 to that in 2008?
Ensure brevity in your answer.  1.03. What is the ratio of the Total Labor Force (in %) in Euro area in 2007 to that in 2008?
Give a very brief answer. 0.99. What is the ratio of the Total Labor Force (in %) of New Caledonia in 2007 to that in 2008?
Your response must be concise. 1.01. What is the ratio of the Total Labor Force (in %) in Saudi Arabia in 2007 to that in 2008?
Your answer should be compact. 1.02. What is the difference between the highest and the second highest Total Labor Force (in %) in Euro area?
Ensure brevity in your answer.  0.46. What is the difference between the highest and the second highest Total Labor Force (in %) of New Caledonia?
Provide a succinct answer. 0.1. What is the difference between the highest and the second highest Total Labor Force (in %) of Saudi Arabia?
Ensure brevity in your answer.  0.3. What is the difference between the highest and the second highest Total Labor Force (in %) in Virgin Islands?
Give a very brief answer. 0. What is the difference between the highest and the lowest Total Labor Force (in %) of Euro area?
Your response must be concise. 3.68. What is the difference between the highest and the lowest Total Labor Force (in %) in New Caledonia?
Ensure brevity in your answer.  1.4. 